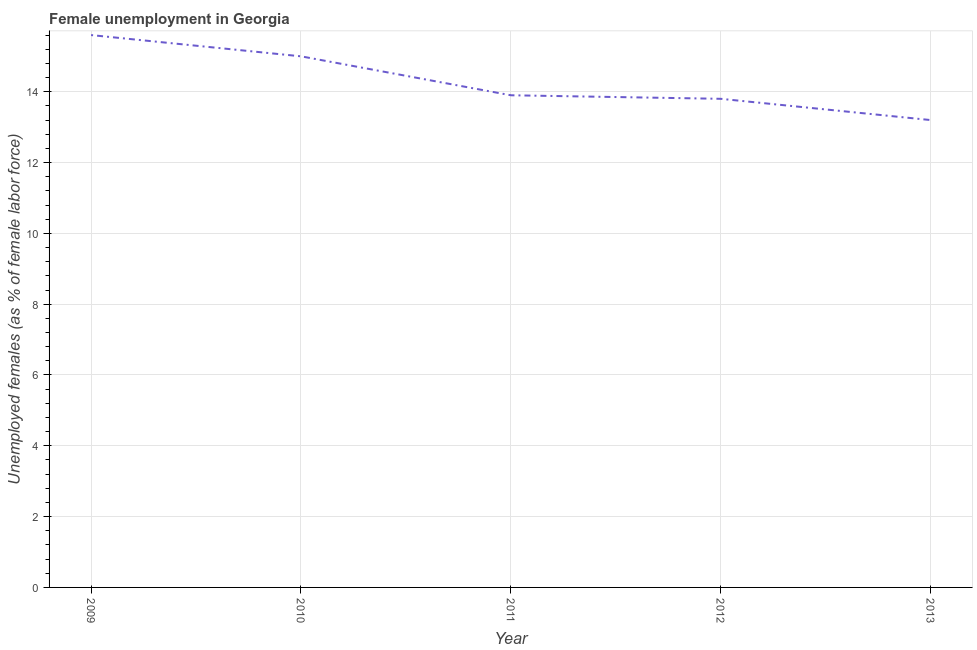What is the unemployed females population in 2013?
Your answer should be compact. 13.2. Across all years, what is the maximum unemployed females population?
Provide a short and direct response. 15.6. Across all years, what is the minimum unemployed females population?
Your response must be concise. 13.2. In which year was the unemployed females population minimum?
Your answer should be very brief. 2013. What is the sum of the unemployed females population?
Your response must be concise. 71.5. What is the difference between the unemployed females population in 2011 and 2013?
Offer a terse response. 0.7. What is the median unemployed females population?
Offer a terse response. 13.9. In how many years, is the unemployed females population greater than 9.2 %?
Provide a short and direct response. 5. What is the ratio of the unemployed females population in 2009 to that in 2010?
Keep it short and to the point. 1.04. Is the unemployed females population in 2010 less than that in 2012?
Ensure brevity in your answer.  No. What is the difference between the highest and the second highest unemployed females population?
Keep it short and to the point. 0.6. What is the difference between the highest and the lowest unemployed females population?
Ensure brevity in your answer.  2.4. In how many years, is the unemployed females population greater than the average unemployed females population taken over all years?
Offer a very short reply. 2. Does the unemployed females population monotonically increase over the years?
Ensure brevity in your answer.  No. How many lines are there?
Make the answer very short. 1. Does the graph contain any zero values?
Your response must be concise. No. What is the title of the graph?
Give a very brief answer. Female unemployment in Georgia. What is the label or title of the Y-axis?
Make the answer very short. Unemployed females (as % of female labor force). What is the Unemployed females (as % of female labor force) of 2009?
Offer a terse response. 15.6. What is the Unemployed females (as % of female labor force) in 2011?
Give a very brief answer. 13.9. What is the Unemployed females (as % of female labor force) in 2012?
Keep it short and to the point. 13.8. What is the Unemployed females (as % of female labor force) of 2013?
Make the answer very short. 13.2. What is the difference between the Unemployed females (as % of female labor force) in 2009 and 2011?
Your answer should be compact. 1.7. What is the difference between the Unemployed females (as % of female labor force) in 2009 and 2013?
Offer a terse response. 2.4. What is the difference between the Unemployed females (as % of female labor force) in 2011 and 2012?
Give a very brief answer. 0.1. What is the difference between the Unemployed females (as % of female labor force) in 2011 and 2013?
Make the answer very short. 0.7. What is the difference between the Unemployed females (as % of female labor force) in 2012 and 2013?
Ensure brevity in your answer.  0.6. What is the ratio of the Unemployed females (as % of female labor force) in 2009 to that in 2010?
Your answer should be very brief. 1.04. What is the ratio of the Unemployed females (as % of female labor force) in 2009 to that in 2011?
Your answer should be compact. 1.12. What is the ratio of the Unemployed females (as % of female labor force) in 2009 to that in 2012?
Your response must be concise. 1.13. What is the ratio of the Unemployed females (as % of female labor force) in 2009 to that in 2013?
Offer a terse response. 1.18. What is the ratio of the Unemployed females (as % of female labor force) in 2010 to that in 2011?
Your response must be concise. 1.08. What is the ratio of the Unemployed females (as % of female labor force) in 2010 to that in 2012?
Ensure brevity in your answer.  1.09. What is the ratio of the Unemployed females (as % of female labor force) in 2010 to that in 2013?
Keep it short and to the point. 1.14. What is the ratio of the Unemployed females (as % of female labor force) in 2011 to that in 2013?
Make the answer very short. 1.05. What is the ratio of the Unemployed females (as % of female labor force) in 2012 to that in 2013?
Offer a very short reply. 1.04. 